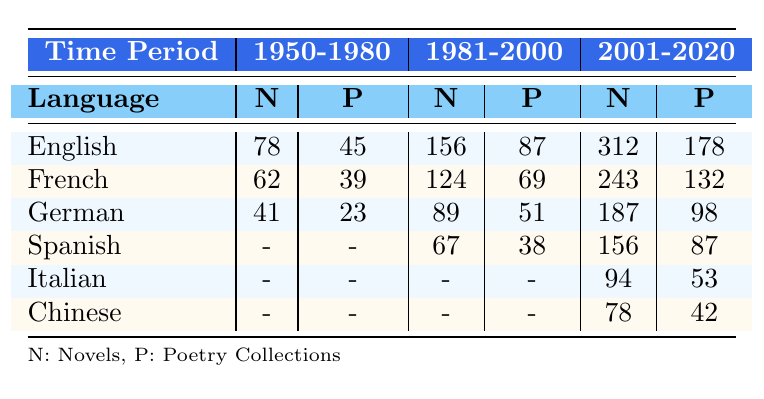What is the total number of novels translated into English during the time period 1981-2000? From the table, the number of novels translated into English during 1981-2000 is given as 156.
Answer: 156 How many poetry collections were translated into French from 1950-1980? The table shows that 39 poetry collections were translated into French during the time period 1950-1980.
Answer: 39 Which language had the highest number of short story collections translated during 2001-2020? According to the table, English had 145 short story collections, which is higher than any other language in that time period.
Answer: English What is the difference in the number of novels translated into German between the periods 1981-2000 and 2001-2020? The table indicates that 89 novels were translated into German from 1981-2000 and 187 from 2001-2020. The difference is 187 - 89 = 98.
Answer: 98 How many total poetry collections were translated into Spanish from 1981-2000 and 2001-2020? In 1981-2000, there were 38 poetry collections, and in 2001-2020, there were 87. Summing these gives 38 + 87 = 125 total poetry collections translated into Spanish.
Answer: 125 True or False: More poetry collections were translated into Italian than into German during 2001-2020. The table shows that there were 53 poetry collections translated into Italian and 98 into German during this period, indicating that the statement is false.
Answer: False What is the average number of novels translated per language during the 1950-1980 period? In the 1950-1980 period, there are 3 languages listed: English (78), French (62), and German (41). Summing these yields 78 + 62 + 41 = 181. Dividing by 3 gives an average of 181 / 3 = 60.33.
Answer: 60.33 Which period saw an increase in the number of novels translated into French, and by how many novels? Comparing the two time periods for French: 1950-1980 had 62 novels and 1981-2000 had 124 novels, which gives a difference of 124 - 62 = 62. This shows an increase in the number of novels translated into French.
Answer: Period 1981-2000, increase of 62 novels How many total short story collections were translated into German over all three time periods? The table shows 19 from 1950-1980, 42 from 1981-2000, and 83 from 2001-2020. Summing these gives 19 + 42 + 83 = 144 total short story collections translated into German.
Answer: 144 